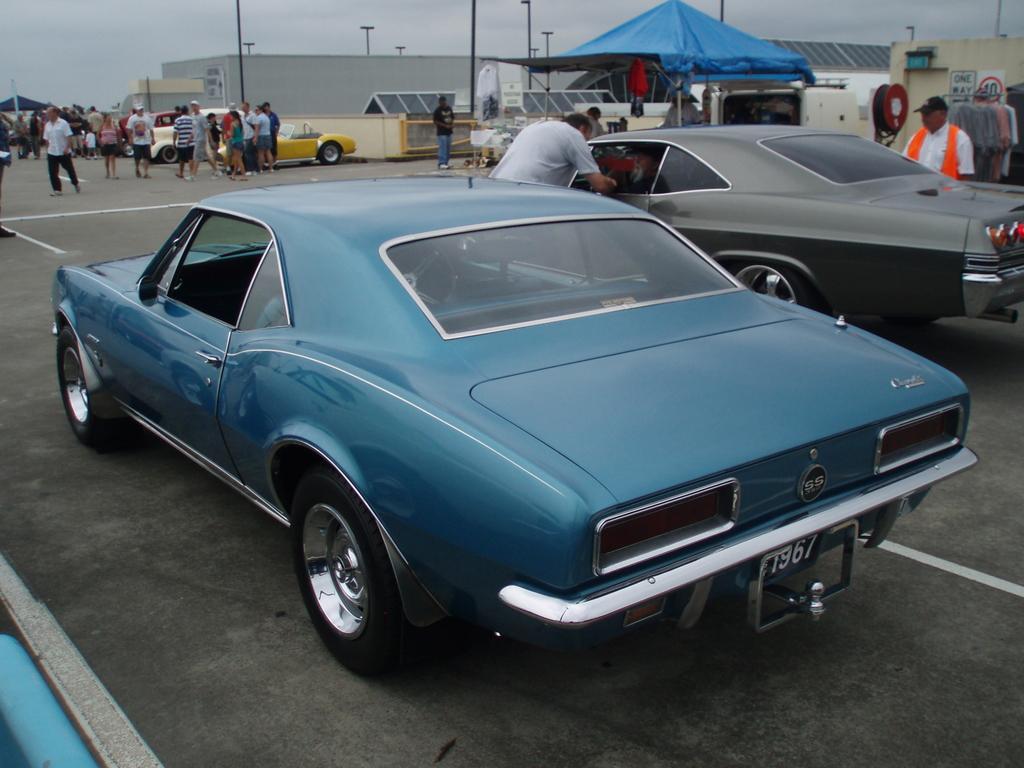Please provide a concise description of this image. In this given picture, I can see a car two cars which is parked and i can see two persons and here are group of people standing and also i can see small shed after that multiple electrical poles. 